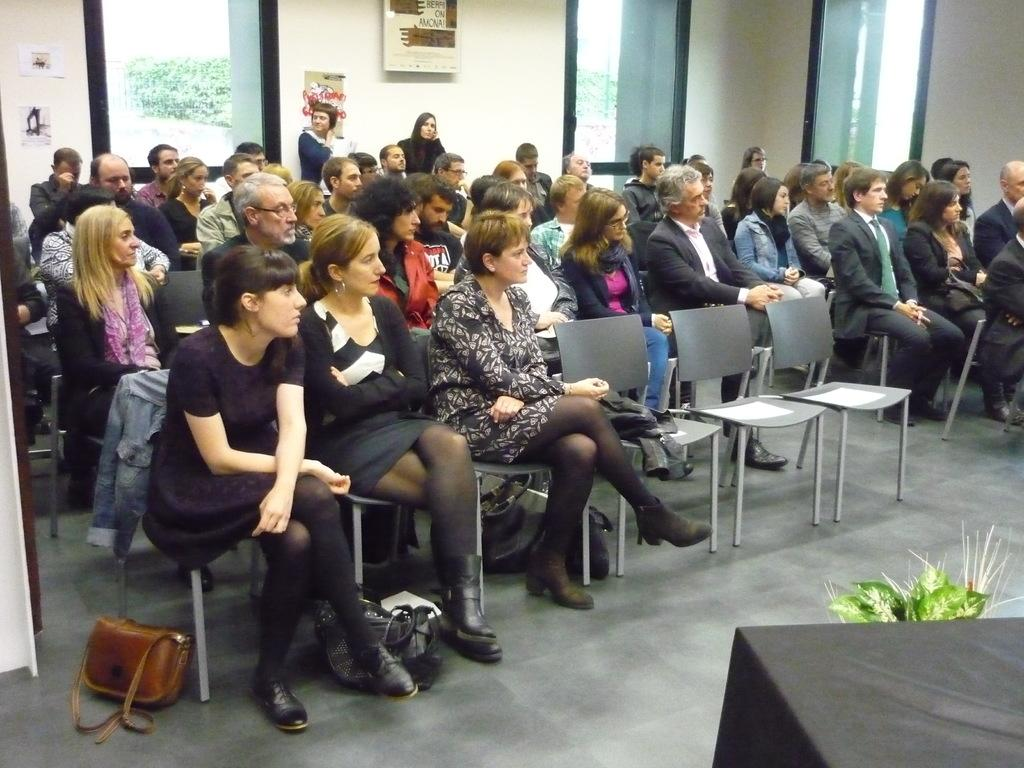What are the people in the image doing? There are many people sitting on chairs in the image. What object can be seen near the people? There is a flower pot in the image. What personal item is visible in the image? There is a handbag in the image. What type of architectural feature is present in the image? There is a glass window in the image. What can be seen through the glass window? Trees are visible through the glass window. What type of wing is visible on the people in the image? There are no wings visible on the people in the image. What snack is being shared among the people in the image? There is no snack, such as popcorn, visible in the image. 